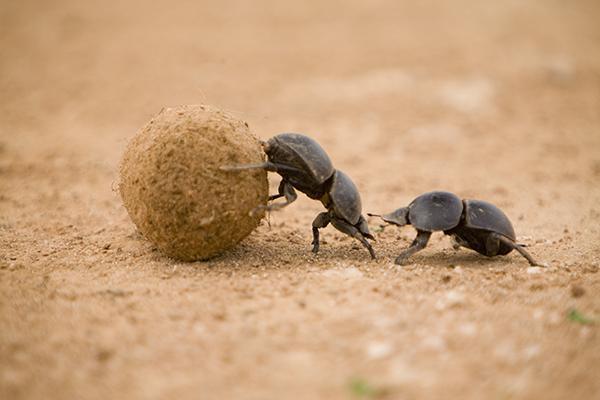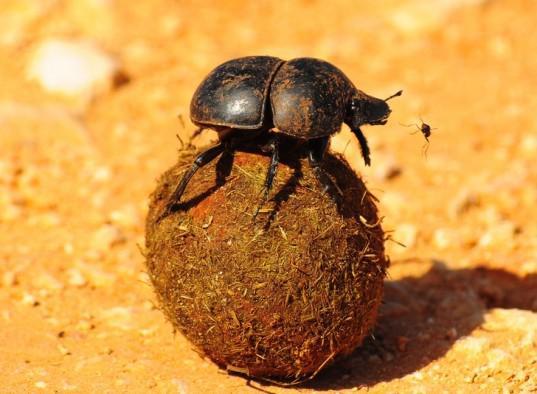The first image is the image on the left, the second image is the image on the right. For the images displayed, is the sentence "There is a beetle that that's at the very top of a dungball." factually correct? Answer yes or no. Yes. The first image is the image on the left, the second image is the image on the right. Given the left and right images, does the statement "There is a beetle that is not in contact with a ball in one image." hold true? Answer yes or no. Yes. 